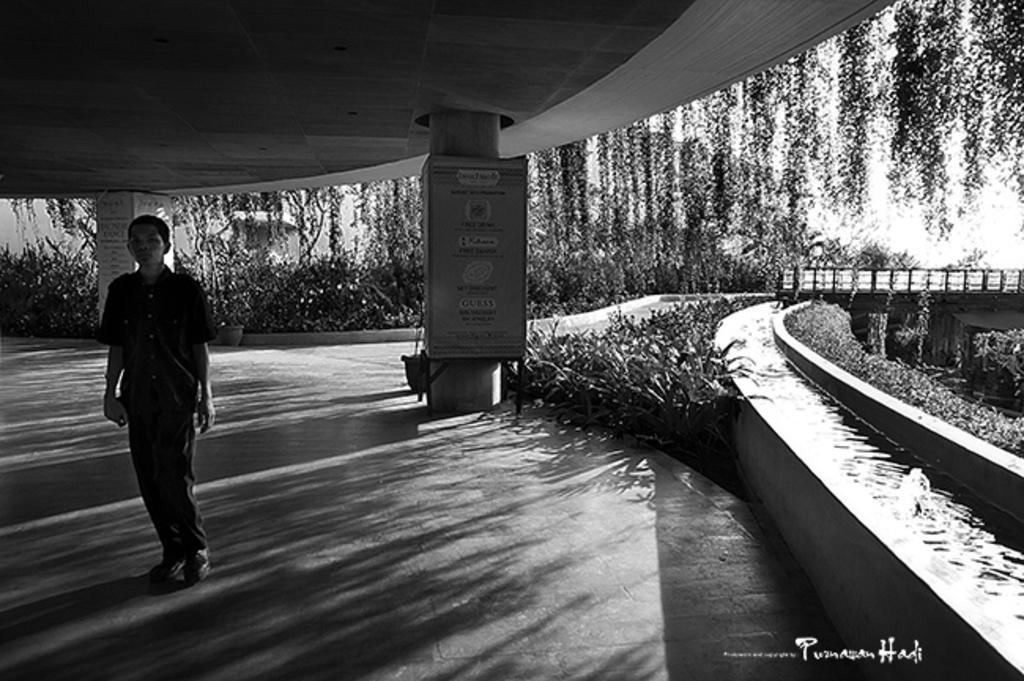What is the color scheme of the image? The image is black and white. What type of signage can be seen in the image? There are hoardings in the image. Can you describe the person in the image? There is a person in the image. What natural element is visible in the image? There is water visible in the image. What type of vegetation is present in the image? There are plants in the image. What type of vest is the person wearing in the image? There is no vest visible in the image; the person is not wearing any clothing that resembles a vest. Can you describe the attack that is happening in the image? There is no attack depicted in the image; it is a peaceful scene featuring a person, hoardings, water, and plants. 